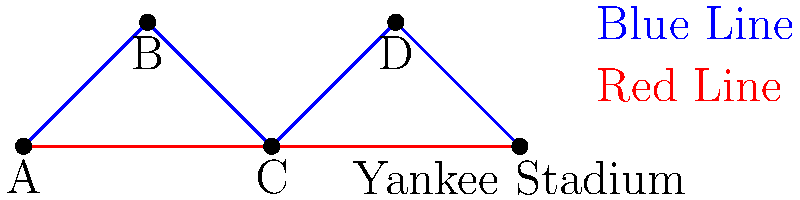As a Yankees fan heading to see the Bronx Bombers play at Yankee Stadium, you're presented with the subway map above. What is the minimum number of different subway lines you need to take to reach Yankee Stadium from station A, assuming you can only travel in the direction of the arrows? Let's analyze this problem step-by-step:

1. We start at station A and need to reach Yankee Stadium.

2. We have two possible routes:
   a) Blue Line: A → B → C → D → Yankee Stadium
   b) Red Line: A → C → Yankee Stadium

3. The Blue Line route:
   - This route uses only one line (the Blue Line) for the entire journey.
   - Number of different lines used: 1

4. The Red Line route:
   - This route also uses only one line (the Red Line) for the entire journey.
   - Number of different lines used: 1

5. Both routes require using only one line to reach Yankee Stadium.

6. Therefore, the minimum number of different subway lines needed is 1.

This problem demonstrates the concept of path connectivity in topology, where we're looking for the most efficient route in terms of the number of different lines used, rather than the number of stops.
Answer: 1 